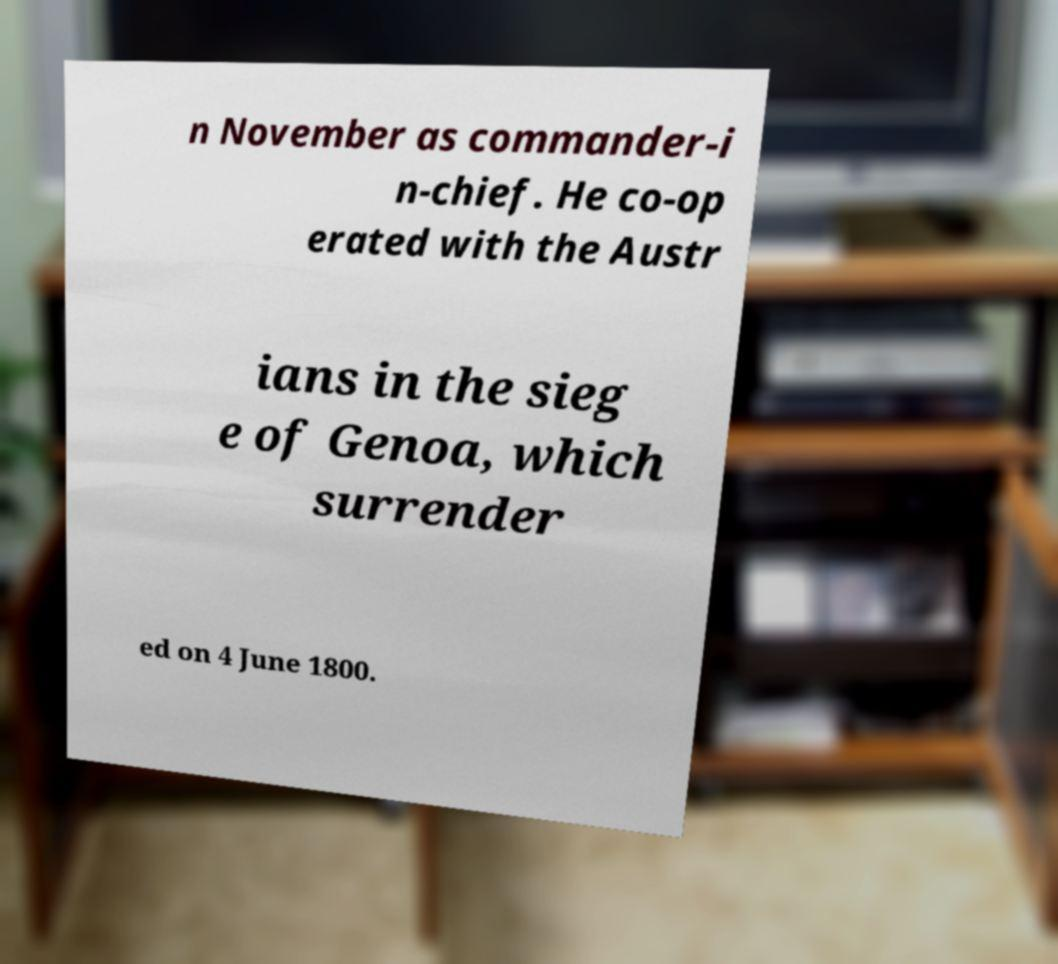Could you extract and type out the text from this image? n November as commander-i n-chief. He co-op erated with the Austr ians in the sieg e of Genoa, which surrender ed on 4 June 1800. 